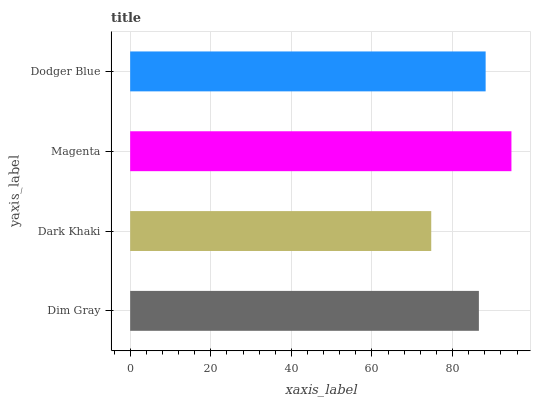Is Dark Khaki the minimum?
Answer yes or no. Yes. Is Magenta the maximum?
Answer yes or no. Yes. Is Magenta the minimum?
Answer yes or no. No. Is Dark Khaki the maximum?
Answer yes or no. No. Is Magenta greater than Dark Khaki?
Answer yes or no. Yes. Is Dark Khaki less than Magenta?
Answer yes or no. Yes. Is Dark Khaki greater than Magenta?
Answer yes or no. No. Is Magenta less than Dark Khaki?
Answer yes or no. No. Is Dodger Blue the high median?
Answer yes or no. Yes. Is Dim Gray the low median?
Answer yes or no. Yes. Is Magenta the high median?
Answer yes or no. No. Is Dark Khaki the low median?
Answer yes or no. No. 